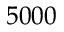<formula> <loc_0><loc_0><loc_500><loc_500>5 0 0 0</formula> 